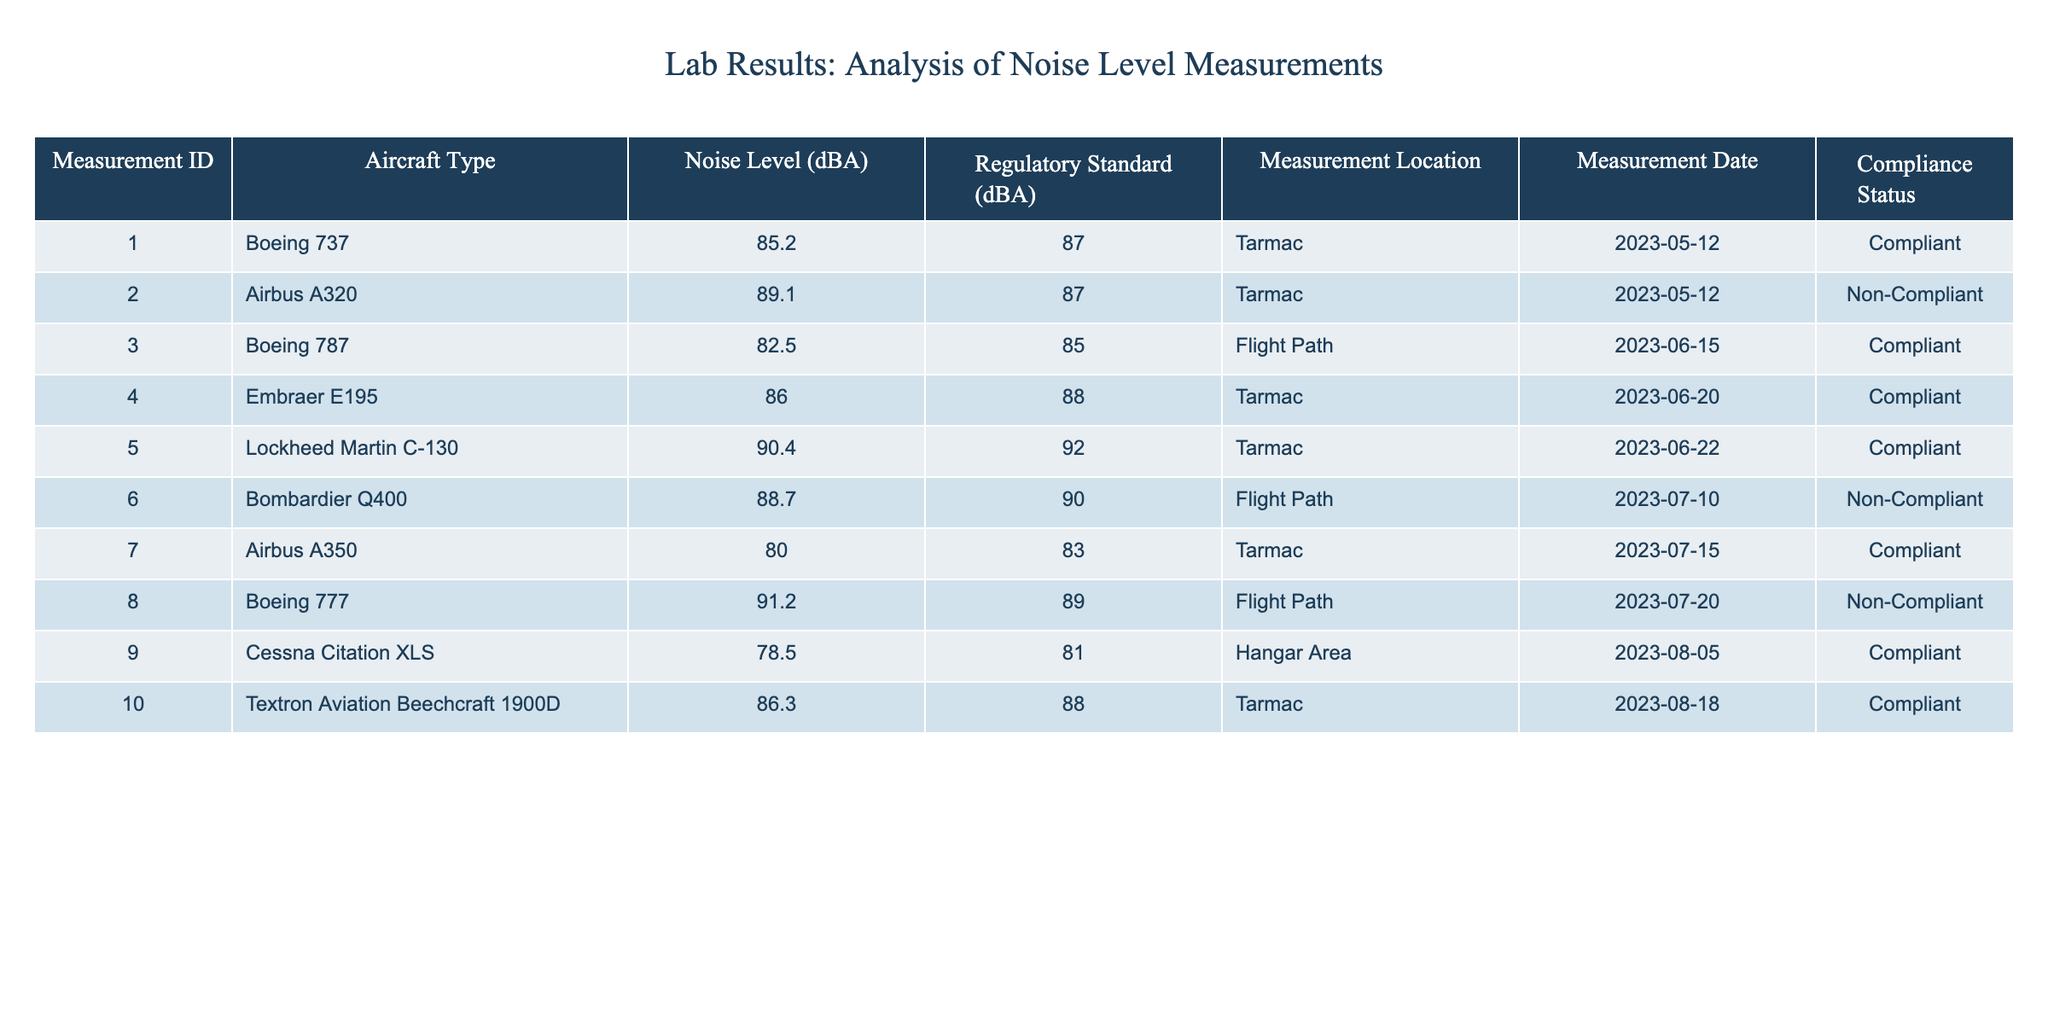What is the compliance status of the Airbus A320? The table shows that the measurement for the Airbus A320 has a compliance status of "Non-Compliant."
Answer: Non-Compliant How many aircraft types measured have a noise level above 85 dBA? The table lists several aircraft types. I will count the number of measurements with a noise level greater than 85 dBA, which are 2 (Airbus A320 and Boeing 777) and 4 additional compliant measurements (Lockheed Martin C-130, Bombardier Q400, Embraer E195, and Textron Aviation Beechcraft 1900D). So, in total, there are 5 aircraft types.
Answer: 5 What is the difference between the highest and lowest noise levels recorded? The highest noise level recorded in the table is 91.2 dBA (Boeing 777), and the lowest is 78.5 dBA (Cessna Citation XLS). The difference is 91.2 - 78.5 = 12.7 dBA.
Answer: 12.7 dBA Are there any aircraft types that have been measured at a noise level below the regulatory standard? By examining the table, the Airbus A320 and Boeing 777 both have noise levels (89.1 dBA and 91.2 dBA respectively) that exceed their regulatory standards, meaning all other aircraft measured are compliant with their noise levels below the regulatory standards. Thus, there are no aircraft below the standard.
Answer: No What percentage of measurements taken were compliant with regulations? There are 10 measurements in total, and 7 of them are marked as compliant. To find the percentage, divide 7 by 10 and multiply by 100, resulting in 70% compliance.
Answer: 70% What is the average noise level of all compliant measurements? The compliant measurements are: 85.2 dBA, 82.5 dBA, 86.0 dBA, 90.4 dBA, 80.0 dBA, 78.5 dBA, and 86.3 dBA. Adding these values gives 85.3 dBA. With 7 compliant measurements, the average is 85.3 / 7 = approximately 85.3 dBA.
Answer: 85.3 dBA Which measurement location had the most non-compliant measurements? There are two non-compliant measurements for Tarmac (Airbus A320 and Embraer E195). Flight Path has one (Boeing 777). Thus, Tarmac has the most non-compliant measurements.
Answer: Tarmac What is the maximum noise level that met compliance? I will identify the maximum compliant noise level by reviewing the compliant measurements. The highest compliant measurement is 90.4 dBA (Lockheed Martin C-130).
Answer: 90.4 dBA 